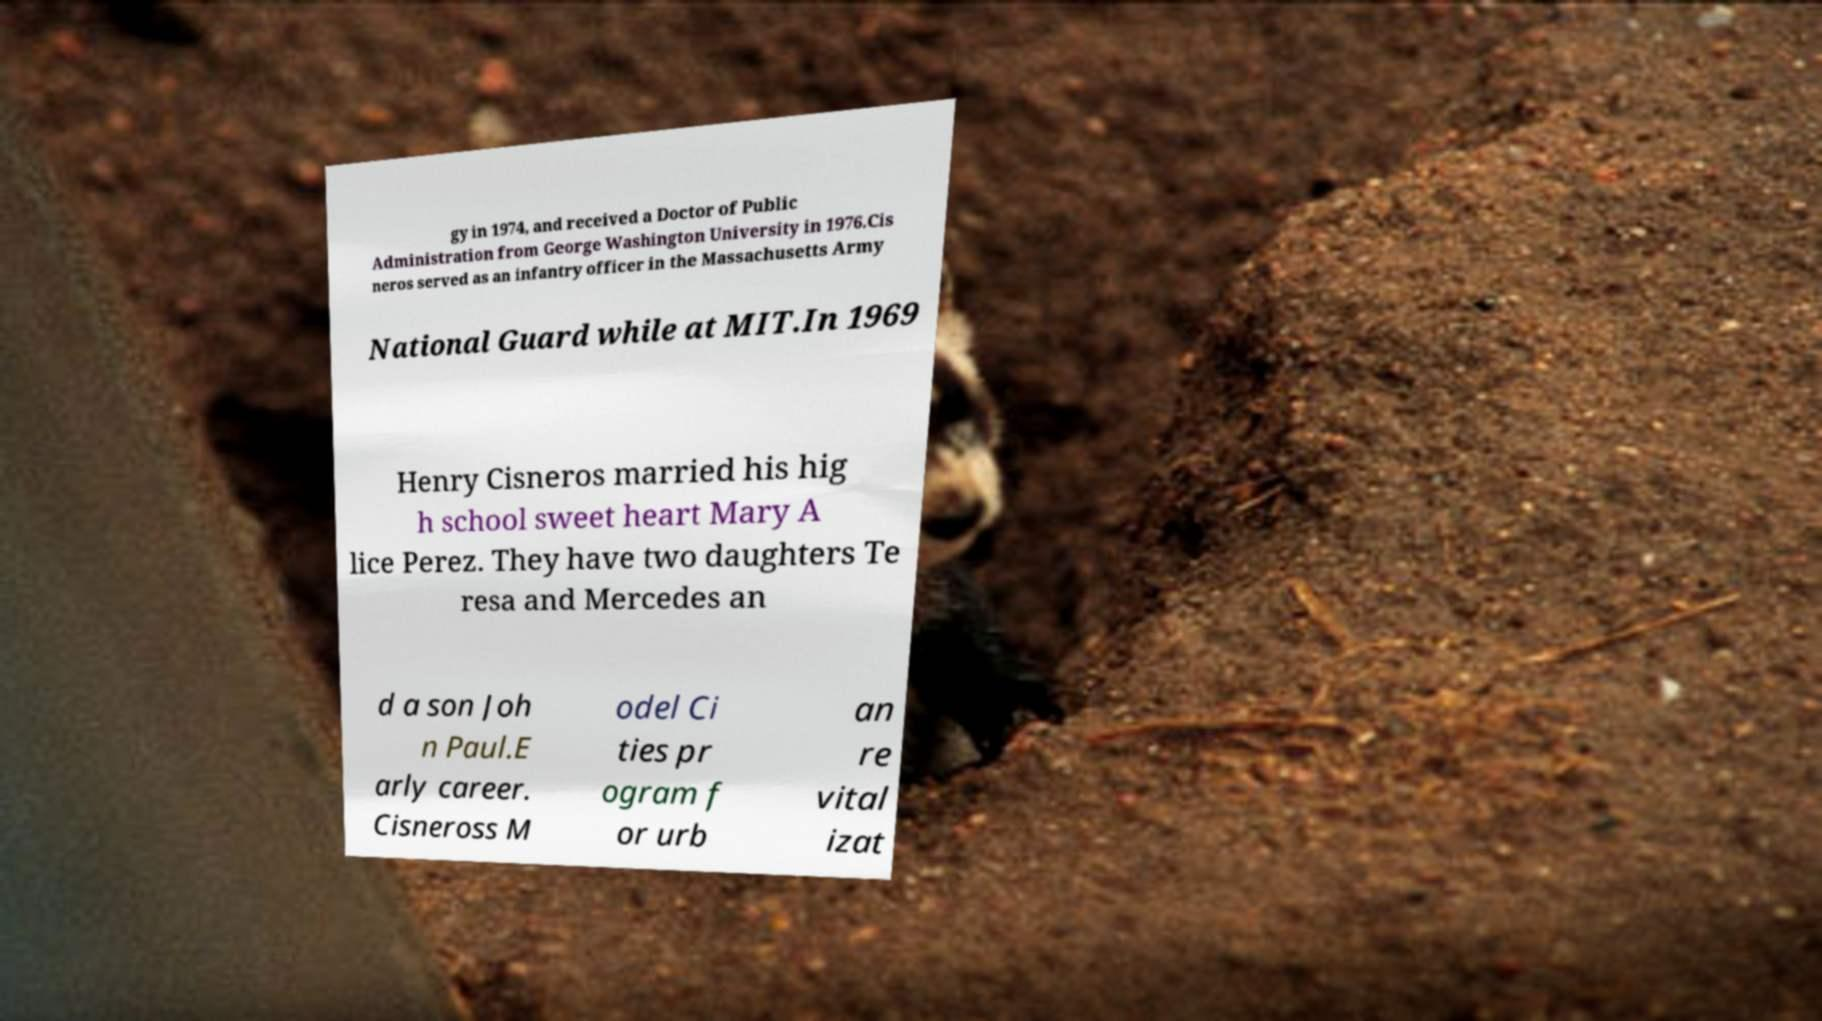Can you read and provide the text displayed in the image?This photo seems to have some interesting text. Can you extract and type it out for me? gy in 1974, and received a Doctor of Public Administration from George Washington University in 1976.Cis neros served as an infantry officer in the Massachusetts Army National Guard while at MIT.In 1969 Henry Cisneros married his hig h school sweet heart Mary A lice Perez. They have two daughters Te resa and Mercedes an d a son Joh n Paul.E arly career. Cisneross M odel Ci ties pr ogram f or urb an re vital izat 